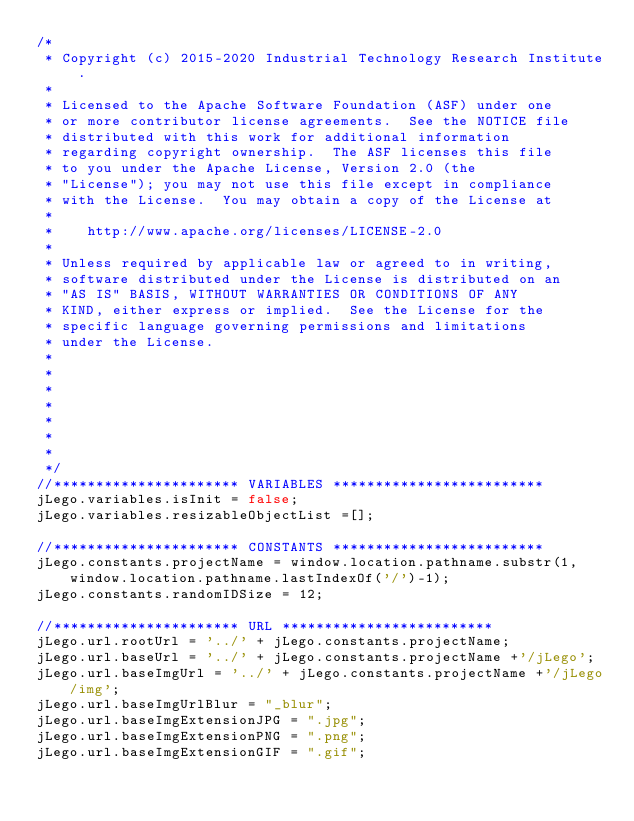Convert code to text. <code><loc_0><loc_0><loc_500><loc_500><_JavaScript_>/*
 * Copyright (c) 2015-2020 Industrial Technology Research Institute.
 *
 * Licensed to the Apache Software Foundation (ASF) under one
 * or more contributor license agreements.  See the NOTICE file
 * distributed with this work for additional information
 * regarding copyright ownership.  The ASF licenses this file
 * to you under the Apache License, Version 2.0 (the
 * "License"); you may not use this file except in compliance
 * with the License.  You may obtain a copy of the License at
 *
 *    http://www.apache.org/licenses/LICENSE-2.0
 *
 * Unless required by applicable law or agreed to in writing,
 * software distributed under the License is distributed on an
 * "AS IS" BASIS, WITHOUT WARRANTIES OR CONDITIONS OF ANY
 * KIND, either express or implied.  See the License for the
 * specific language governing permissions and limitations
 * under the License.
 *
 *
 *
 *
 *
 *
 *  
 */
//********************** VARIABLES *************************
jLego.variables.isInit = false;
jLego.variables.resizableObjectList =[];

//********************** CONSTANTS *************************
jLego.constants.projectName = window.location.pathname.substr(1, window.location.pathname.lastIndexOf('/')-1);
jLego.constants.randomIDSize = 12;

//********************** URL *************************
jLego.url.rootUrl = '../' + jLego.constants.projectName;
jLego.url.baseUrl = '../' + jLego.constants.projectName +'/jLego';
jLego.url.baseImgUrl = '../' + jLego.constants.projectName +'/jLego/img';
jLego.url.baseImgUrlBlur = "_blur";
jLego.url.baseImgExtensionJPG = ".jpg";
jLego.url.baseImgExtensionPNG = ".png";
jLego.url.baseImgExtensionGIF = ".gif";</code> 